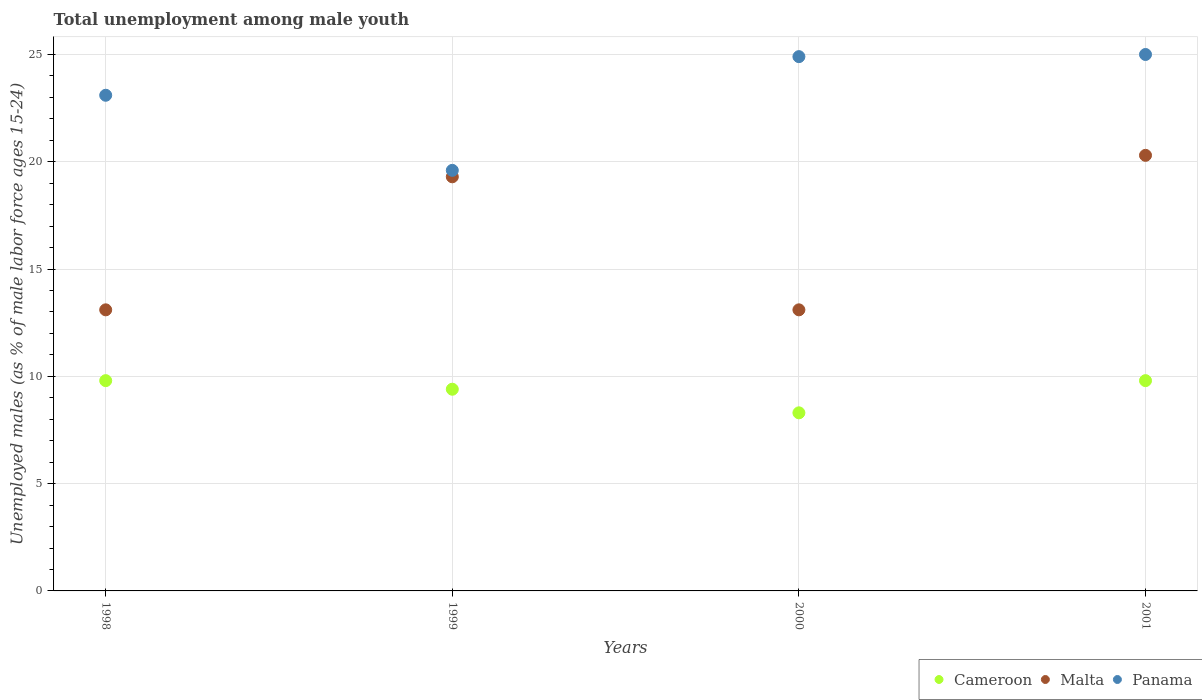How many different coloured dotlines are there?
Keep it short and to the point. 3. What is the percentage of unemployed males in in Malta in 1998?
Your response must be concise. 13.1. Across all years, what is the maximum percentage of unemployed males in in Cameroon?
Your answer should be compact. 9.8. Across all years, what is the minimum percentage of unemployed males in in Malta?
Provide a succinct answer. 13.1. In which year was the percentage of unemployed males in in Cameroon maximum?
Provide a short and direct response. 1998. In which year was the percentage of unemployed males in in Cameroon minimum?
Offer a terse response. 2000. What is the total percentage of unemployed males in in Panama in the graph?
Ensure brevity in your answer.  92.6. What is the difference between the percentage of unemployed males in in Cameroon in 1999 and that in 2001?
Your answer should be compact. -0.4. What is the difference between the percentage of unemployed males in in Panama in 1999 and the percentage of unemployed males in in Cameroon in 2000?
Provide a short and direct response. 11.3. What is the average percentage of unemployed males in in Cameroon per year?
Provide a short and direct response. 9.33. In the year 1999, what is the difference between the percentage of unemployed males in in Panama and percentage of unemployed males in in Cameroon?
Offer a very short reply. 10.2. In how many years, is the percentage of unemployed males in in Malta greater than 9 %?
Your response must be concise. 4. What is the ratio of the percentage of unemployed males in in Cameroon in 1998 to that in 2000?
Ensure brevity in your answer.  1.18. Is the percentage of unemployed males in in Malta in 2000 less than that in 2001?
Provide a short and direct response. Yes. What is the difference between the highest and the lowest percentage of unemployed males in in Malta?
Give a very brief answer. 7.2. Is the sum of the percentage of unemployed males in in Malta in 1999 and 2001 greater than the maximum percentage of unemployed males in in Panama across all years?
Provide a succinct answer. Yes. Is the percentage of unemployed males in in Cameroon strictly greater than the percentage of unemployed males in in Malta over the years?
Your answer should be compact. No. How many dotlines are there?
Your response must be concise. 3. How many years are there in the graph?
Make the answer very short. 4. Are the values on the major ticks of Y-axis written in scientific E-notation?
Offer a terse response. No. Does the graph contain any zero values?
Give a very brief answer. No. How many legend labels are there?
Keep it short and to the point. 3. What is the title of the graph?
Ensure brevity in your answer.  Total unemployment among male youth. Does "Canada" appear as one of the legend labels in the graph?
Ensure brevity in your answer.  No. What is the label or title of the X-axis?
Make the answer very short. Years. What is the label or title of the Y-axis?
Keep it short and to the point. Unemployed males (as % of male labor force ages 15-24). What is the Unemployed males (as % of male labor force ages 15-24) in Cameroon in 1998?
Offer a very short reply. 9.8. What is the Unemployed males (as % of male labor force ages 15-24) in Malta in 1998?
Keep it short and to the point. 13.1. What is the Unemployed males (as % of male labor force ages 15-24) of Panama in 1998?
Give a very brief answer. 23.1. What is the Unemployed males (as % of male labor force ages 15-24) of Cameroon in 1999?
Make the answer very short. 9.4. What is the Unemployed males (as % of male labor force ages 15-24) in Malta in 1999?
Offer a very short reply. 19.3. What is the Unemployed males (as % of male labor force ages 15-24) in Panama in 1999?
Give a very brief answer. 19.6. What is the Unemployed males (as % of male labor force ages 15-24) of Cameroon in 2000?
Your answer should be very brief. 8.3. What is the Unemployed males (as % of male labor force ages 15-24) of Malta in 2000?
Offer a very short reply. 13.1. What is the Unemployed males (as % of male labor force ages 15-24) in Panama in 2000?
Ensure brevity in your answer.  24.9. What is the Unemployed males (as % of male labor force ages 15-24) in Cameroon in 2001?
Your answer should be compact. 9.8. What is the Unemployed males (as % of male labor force ages 15-24) of Malta in 2001?
Ensure brevity in your answer.  20.3. What is the Unemployed males (as % of male labor force ages 15-24) in Panama in 2001?
Keep it short and to the point. 25. Across all years, what is the maximum Unemployed males (as % of male labor force ages 15-24) in Cameroon?
Make the answer very short. 9.8. Across all years, what is the maximum Unemployed males (as % of male labor force ages 15-24) in Malta?
Offer a terse response. 20.3. Across all years, what is the maximum Unemployed males (as % of male labor force ages 15-24) of Panama?
Your response must be concise. 25. Across all years, what is the minimum Unemployed males (as % of male labor force ages 15-24) of Cameroon?
Offer a terse response. 8.3. Across all years, what is the minimum Unemployed males (as % of male labor force ages 15-24) of Malta?
Provide a succinct answer. 13.1. Across all years, what is the minimum Unemployed males (as % of male labor force ages 15-24) in Panama?
Offer a very short reply. 19.6. What is the total Unemployed males (as % of male labor force ages 15-24) in Cameroon in the graph?
Your answer should be very brief. 37.3. What is the total Unemployed males (as % of male labor force ages 15-24) in Malta in the graph?
Provide a short and direct response. 65.8. What is the total Unemployed males (as % of male labor force ages 15-24) of Panama in the graph?
Offer a very short reply. 92.6. What is the difference between the Unemployed males (as % of male labor force ages 15-24) of Cameroon in 1998 and that in 1999?
Keep it short and to the point. 0.4. What is the difference between the Unemployed males (as % of male labor force ages 15-24) of Malta in 1998 and that in 1999?
Offer a terse response. -6.2. What is the difference between the Unemployed males (as % of male labor force ages 15-24) of Panama in 1998 and that in 1999?
Provide a succinct answer. 3.5. What is the difference between the Unemployed males (as % of male labor force ages 15-24) of Cameroon in 1998 and that in 2000?
Offer a very short reply. 1.5. What is the difference between the Unemployed males (as % of male labor force ages 15-24) in Malta in 1998 and that in 2000?
Your answer should be very brief. 0. What is the difference between the Unemployed males (as % of male labor force ages 15-24) in Panama in 1998 and that in 2000?
Give a very brief answer. -1.8. What is the difference between the Unemployed males (as % of male labor force ages 15-24) in Cameroon in 1998 and that in 2001?
Give a very brief answer. 0. What is the difference between the Unemployed males (as % of male labor force ages 15-24) in Malta in 1998 and that in 2001?
Give a very brief answer. -7.2. What is the difference between the Unemployed males (as % of male labor force ages 15-24) of Cameroon in 1999 and that in 2000?
Offer a very short reply. 1.1. What is the difference between the Unemployed males (as % of male labor force ages 15-24) of Malta in 1999 and that in 2000?
Your answer should be compact. 6.2. What is the difference between the Unemployed males (as % of male labor force ages 15-24) in Cameroon in 1999 and that in 2001?
Provide a succinct answer. -0.4. What is the difference between the Unemployed males (as % of male labor force ages 15-24) in Cameroon in 2000 and that in 2001?
Provide a short and direct response. -1.5. What is the difference between the Unemployed males (as % of male labor force ages 15-24) of Cameroon in 1998 and the Unemployed males (as % of male labor force ages 15-24) of Panama in 1999?
Make the answer very short. -9.8. What is the difference between the Unemployed males (as % of male labor force ages 15-24) in Malta in 1998 and the Unemployed males (as % of male labor force ages 15-24) in Panama in 1999?
Your answer should be very brief. -6.5. What is the difference between the Unemployed males (as % of male labor force ages 15-24) of Cameroon in 1998 and the Unemployed males (as % of male labor force ages 15-24) of Malta in 2000?
Keep it short and to the point. -3.3. What is the difference between the Unemployed males (as % of male labor force ages 15-24) in Cameroon in 1998 and the Unemployed males (as % of male labor force ages 15-24) in Panama in 2000?
Give a very brief answer. -15.1. What is the difference between the Unemployed males (as % of male labor force ages 15-24) in Malta in 1998 and the Unemployed males (as % of male labor force ages 15-24) in Panama in 2000?
Offer a terse response. -11.8. What is the difference between the Unemployed males (as % of male labor force ages 15-24) of Cameroon in 1998 and the Unemployed males (as % of male labor force ages 15-24) of Panama in 2001?
Provide a succinct answer. -15.2. What is the difference between the Unemployed males (as % of male labor force ages 15-24) of Cameroon in 1999 and the Unemployed males (as % of male labor force ages 15-24) of Malta in 2000?
Your response must be concise. -3.7. What is the difference between the Unemployed males (as % of male labor force ages 15-24) in Cameroon in 1999 and the Unemployed males (as % of male labor force ages 15-24) in Panama in 2000?
Offer a very short reply. -15.5. What is the difference between the Unemployed males (as % of male labor force ages 15-24) of Cameroon in 1999 and the Unemployed males (as % of male labor force ages 15-24) of Panama in 2001?
Keep it short and to the point. -15.6. What is the difference between the Unemployed males (as % of male labor force ages 15-24) in Malta in 1999 and the Unemployed males (as % of male labor force ages 15-24) in Panama in 2001?
Offer a very short reply. -5.7. What is the difference between the Unemployed males (as % of male labor force ages 15-24) of Cameroon in 2000 and the Unemployed males (as % of male labor force ages 15-24) of Panama in 2001?
Your answer should be very brief. -16.7. What is the average Unemployed males (as % of male labor force ages 15-24) of Cameroon per year?
Give a very brief answer. 9.32. What is the average Unemployed males (as % of male labor force ages 15-24) of Malta per year?
Provide a short and direct response. 16.45. What is the average Unemployed males (as % of male labor force ages 15-24) in Panama per year?
Ensure brevity in your answer.  23.15. In the year 1998, what is the difference between the Unemployed males (as % of male labor force ages 15-24) in Cameroon and Unemployed males (as % of male labor force ages 15-24) in Malta?
Your answer should be very brief. -3.3. In the year 1998, what is the difference between the Unemployed males (as % of male labor force ages 15-24) in Cameroon and Unemployed males (as % of male labor force ages 15-24) in Panama?
Offer a very short reply. -13.3. In the year 1999, what is the difference between the Unemployed males (as % of male labor force ages 15-24) of Cameroon and Unemployed males (as % of male labor force ages 15-24) of Malta?
Your answer should be very brief. -9.9. In the year 1999, what is the difference between the Unemployed males (as % of male labor force ages 15-24) in Malta and Unemployed males (as % of male labor force ages 15-24) in Panama?
Keep it short and to the point. -0.3. In the year 2000, what is the difference between the Unemployed males (as % of male labor force ages 15-24) in Cameroon and Unemployed males (as % of male labor force ages 15-24) in Malta?
Offer a terse response. -4.8. In the year 2000, what is the difference between the Unemployed males (as % of male labor force ages 15-24) in Cameroon and Unemployed males (as % of male labor force ages 15-24) in Panama?
Provide a succinct answer. -16.6. In the year 2001, what is the difference between the Unemployed males (as % of male labor force ages 15-24) of Cameroon and Unemployed males (as % of male labor force ages 15-24) of Panama?
Your answer should be compact. -15.2. What is the ratio of the Unemployed males (as % of male labor force ages 15-24) in Cameroon in 1998 to that in 1999?
Ensure brevity in your answer.  1.04. What is the ratio of the Unemployed males (as % of male labor force ages 15-24) of Malta in 1998 to that in 1999?
Offer a terse response. 0.68. What is the ratio of the Unemployed males (as % of male labor force ages 15-24) in Panama in 1998 to that in 1999?
Offer a terse response. 1.18. What is the ratio of the Unemployed males (as % of male labor force ages 15-24) in Cameroon in 1998 to that in 2000?
Provide a short and direct response. 1.18. What is the ratio of the Unemployed males (as % of male labor force ages 15-24) in Panama in 1998 to that in 2000?
Provide a short and direct response. 0.93. What is the ratio of the Unemployed males (as % of male labor force ages 15-24) of Malta in 1998 to that in 2001?
Give a very brief answer. 0.65. What is the ratio of the Unemployed males (as % of male labor force ages 15-24) of Panama in 1998 to that in 2001?
Offer a terse response. 0.92. What is the ratio of the Unemployed males (as % of male labor force ages 15-24) in Cameroon in 1999 to that in 2000?
Offer a terse response. 1.13. What is the ratio of the Unemployed males (as % of male labor force ages 15-24) in Malta in 1999 to that in 2000?
Offer a terse response. 1.47. What is the ratio of the Unemployed males (as % of male labor force ages 15-24) in Panama in 1999 to that in 2000?
Provide a succinct answer. 0.79. What is the ratio of the Unemployed males (as % of male labor force ages 15-24) in Cameroon in 1999 to that in 2001?
Provide a short and direct response. 0.96. What is the ratio of the Unemployed males (as % of male labor force ages 15-24) of Malta in 1999 to that in 2001?
Provide a succinct answer. 0.95. What is the ratio of the Unemployed males (as % of male labor force ages 15-24) of Panama in 1999 to that in 2001?
Your answer should be compact. 0.78. What is the ratio of the Unemployed males (as % of male labor force ages 15-24) of Cameroon in 2000 to that in 2001?
Keep it short and to the point. 0.85. What is the ratio of the Unemployed males (as % of male labor force ages 15-24) in Malta in 2000 to that in 2001?
Offer a very short reply. 0.65. What is the difference between the highest and the second highest Unemployed males (as % of male labor force ages 15-24) in Cameroon?
Keep it short and to the point. 0. What is the difference between the highest and the second highest Unemployed males (as % of male labor force ages 15-24) of Malta?
Your response must be concise. 1. What is the difference between the highest and the lowest Unemployed males (as % of male labor force ages 15-24) of Malta?
Offer a terse response. 7.2. 